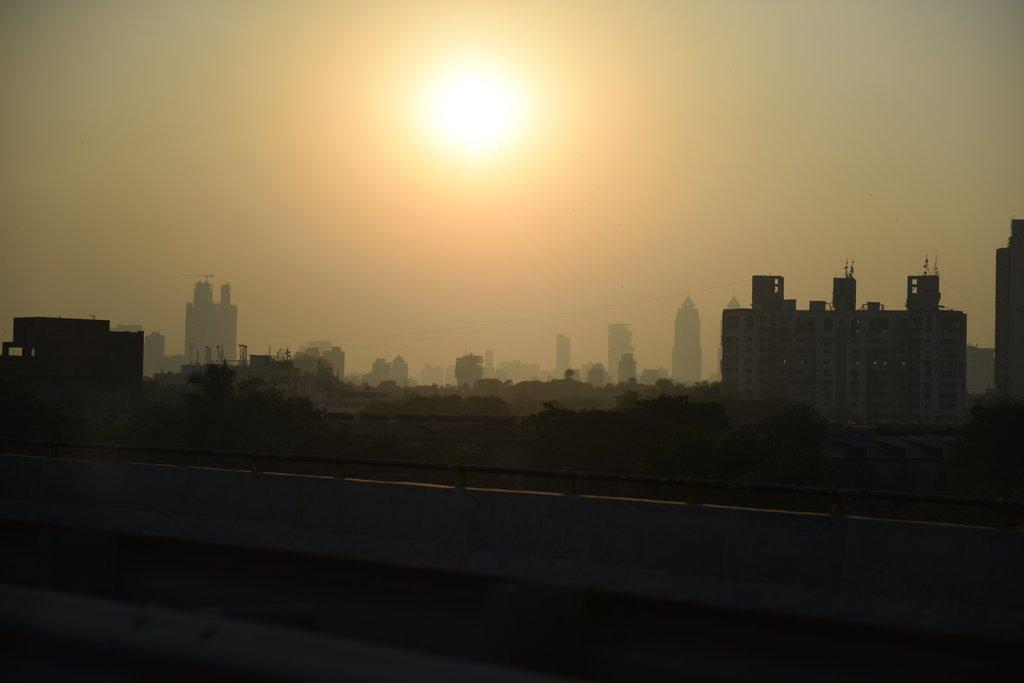What type of natural elements can be seen in the background of the image? There are trees in the background of the image. What type of man-made structures are visible in the background of the image? There are buildings in the background of the image. What kind of device is present in the background of the image? There is a rotator in the background of the image. What celestial body is visible at the top of the image? The sun is visible at the top of the image. What is the color of the bottom part of the image? The bottom of the image appears to be black in color. How does the beginner interact with the son in the image? There is no son or beginner present in the image. What type of mist can be seen surrounding the trees in the image? There is no mist present in the image; the trees are visible without any mist. 